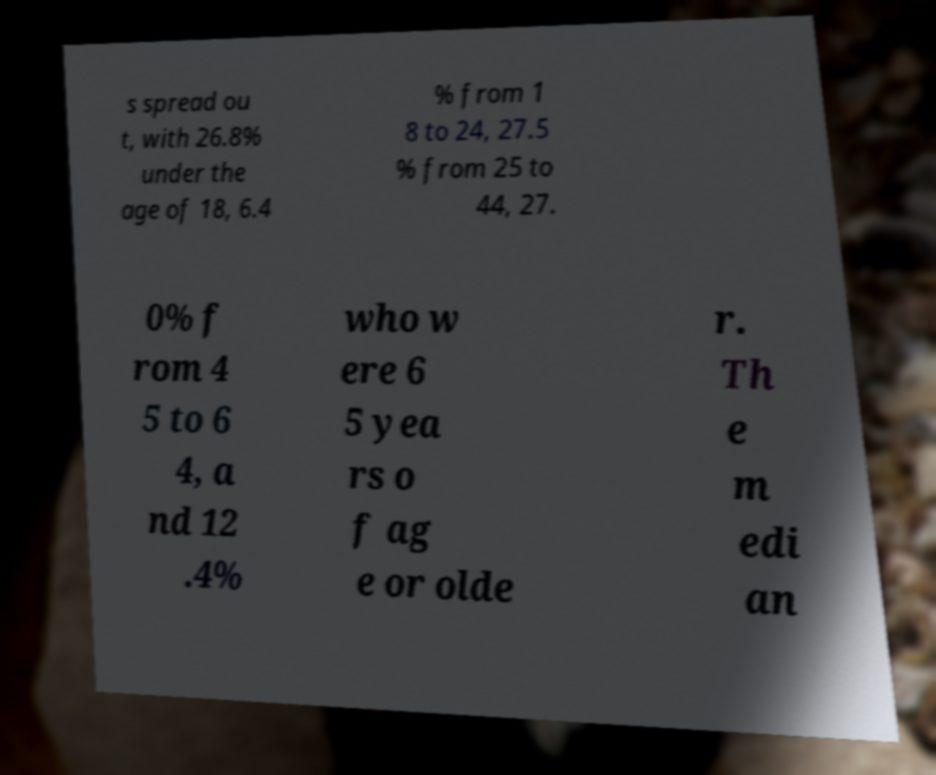What messages or text are displayed in this image? I need them in a readable, typed format. s spread ou t, with 26.8% under the age of 18, 6.4 % from 1 8 to 24, 27.5 % from 25 to 44, 27. 0% f rom 4 5 to 6 4, a nd 12 .4% who w ere 6 5 yea rs o f ag e or olde r. Th e m edi an 